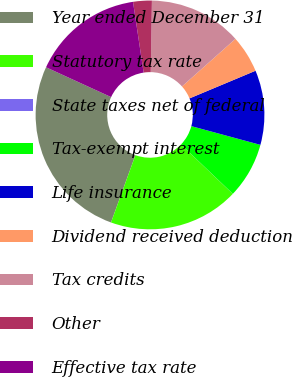Convert chart. <chart><loc_0><loc_0><loc_500><loc_500><pie_chart><fcel>Year ended December 31<fcel>Statutory tax rate<fcel>State taxes net of federal<fcel>Tax-exempt interest<fcel>Life insurance<fcel>Dividend received deduction<fcel>Tax credits<fcel>Other<fcel>Effective tax rate<nl><fcel>26.31%<fcel>18.42%<fcel>0.01%<fcel>7.9%<fcel>10.53%<fcel>5.27%<fcel>13.16%<fcel>2.64%<fcel>15.79%<nl></chart> 